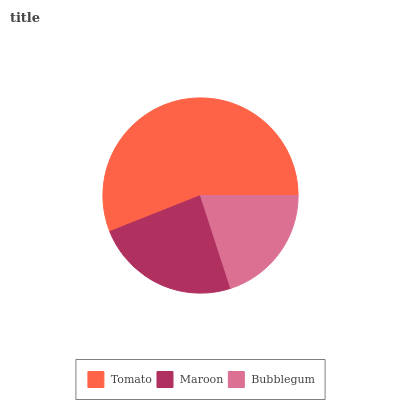Is Bubblegum the minimum?
Answer yes or no. Yes. Is Tomato the maximum?
Answer yes or no. Yes. Is Maroon the minimum?
Answer yes or no. No. Is Maroon the maximum?
Answer yes or no. No. Is Tomato greater than Maroon?
Answer yes or no. Yes. Is Maroon less than Tomato?
Answer yes or no. Yes. Is Maroon greater than Tomato?
Answer yes or no. No. Is Tomato less than Maroon?
Answer yes or no. No. Is Maroon the high median?
Answer yes or no. Yes. Is Maroon the low median?
Answer yes or no. Yes. Is Bubblegum the high median?
Answer yes or no. No. Is Bubblegum the low median?
Answer yes or no. No. 